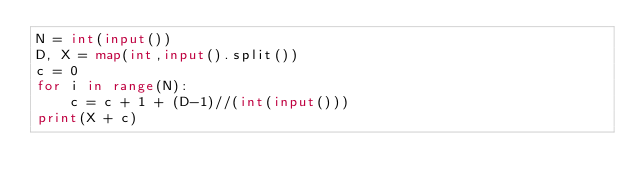<code> <loc_0><loc_0><loc_500><loc_500><_Python_>N = int(input())
D, X = map(int,input().split())
c = 0
for i in range(N):
    c = c + 1 + (D-1)//(int(input()))
print(X + c)</code> 